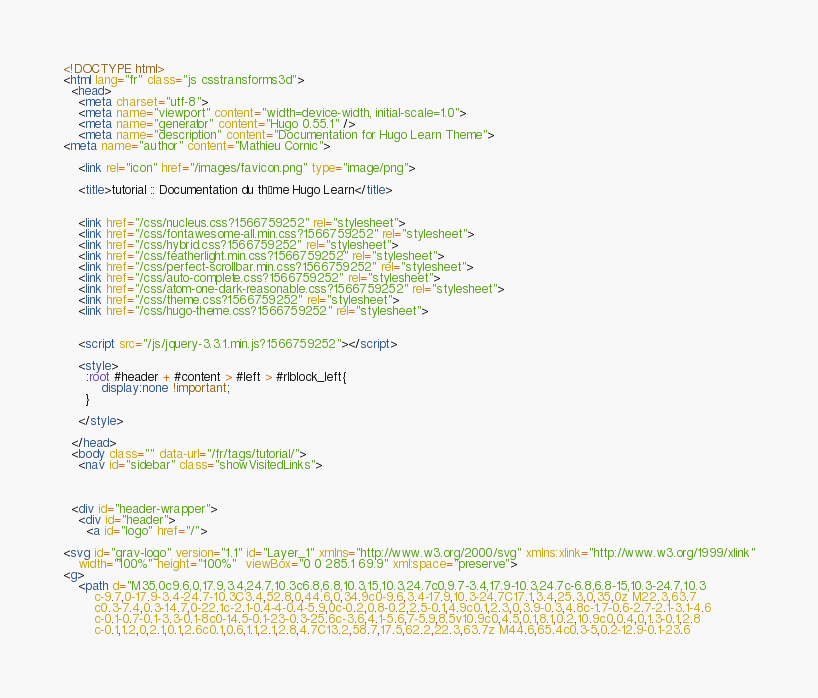<code> <loc_0><loc_0><loc_500><loc_500><_HTML_><!DOCTYPE html>
<html lang="fr" class="js csstransforms3d">
  <head>
    <meta charset="utf-8">
    <meta name="viewport" content="width=device-width, initial-scale=1.0">
    <meta name="generator" content="Hugo 0.55.1" />
    <meta name="description" content="Documentation for Hugo Learn Theme">
<meta name="author" content="Mathieu Cornic">

    <link rel="icon" href="/images/favicon.png" type="image/png">

    <title>tutorial :: Documentation du thème Hugo Learn</title>

    
    <link href="/css/nucleus.css?1566759252" rel="stylesheet">
    <link href="/css/fontawesome-all.min.css?1566759252" rel="stylesheet">
    <link href="/css/hybrid.css?1566759252" rel="stylesheet">
    <link href="/css/featherlight.min.css?1566759252" rel="stylesheet">
    <link href="/css/perfect-scrollbar.min.css?1566759252" rel="stylesheet">
    <link href="/css/auto-complete.css?1566759252" rel="stylesheet">
    <link href="/css/atom-one-dark-reasonable.css?1566759252" rel="stylesheet">
    <link href="/css/theme.css?1566759252" rel="stylesheet">
    <link href="/css/hugo-theme.css?1566759252" rel="stylesheet">
    

    <script src="/js/jquery-3.3.1.min.js?1566759252"></script>

    <style>
      :root #header + #content > #left > #rlblock_left{
          display:none !important;
      }
      
    </style>
    
  </head>
  <body class="" data-url="/fr/tags/tutorial/">
    <nav id="sidebar" class="showVisitedLinks">



  <div id="header-wrapper">
    <div id="header">
      <a id="logo" href="/">

<svg id="grav-logo" version="1.1" id="Layer_1" xmlns="http://www.w3.org/2000/svg" xmlns:xlink="http://www.w3.org/1999/xlink"
	width="100%" height="100%"  viewBox="0 0 285.1 69.9" xml:space="preserve">
<g>
	<path d="M35,0c9.6,0,17.9,3.4,24.7,10.3c6.8,6.8,10.3,15,10.3,24.7c0,9.7-3.4,17.9-10.3,24.7c-6.8,6.8-15,10.3-24.7,10.3
		c-9.7,0-17.9-3.4-24.7-10.3C3.4,52.8,0,44.6,0,34.9c0-9.6,3.4-17.9,10.3-24.7C17.1,3.4,25.3,0,35,0z M22.3,63.7
		c0.3-7.4,0.3-14.7,0-22.1c-2.1-0.4-4-0.4-5.9,0c-0.2,0.8-0.2,2.5-0.1,4.9c0.1,2.3,0,3.9-0.3,4.8c-1.7-0.6-2.7-2.1-3.1-4.6
		c-0.1-0.7-0.1-3.3-0.1-8c0-14.5-0.1-23-0.3-25.6c-3.6,4.1-5.6,7-5.9,8.5v10.9c0,4.5,0.1,8.1,0.2,10.9c0,0.4,0,1.3-0.1,2.8
		c-0.1,1.2,0,2.1,0.1,2.6c0.1,0.6,1.1,2.1,2.8,4.7C13.2,58.7,17.5,62.2,22.3,63.7z M44.6,65.4c0.3-5,0.2-12.9-0.1-23.6</code> 